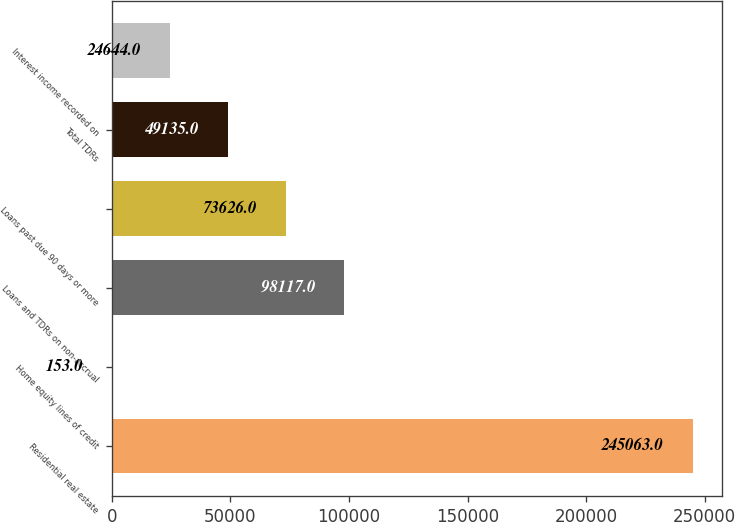Convert chart to OTSL. <chart><loc_0><loc_0><loc_500><loc_500><bar_chart><fcel>Residential real estate<fcel>Home equity lines of credit<fcel>Loans and TDRs on non-accrual<fcel>Loans past due 90 days or more<fcel>Total TDRs<fcel>Interest income recorded on<nl><fcel>245063<fcel>153<fcel>98117<fcel>73626<fcel>49135<fcel>24644<nl></chart> 